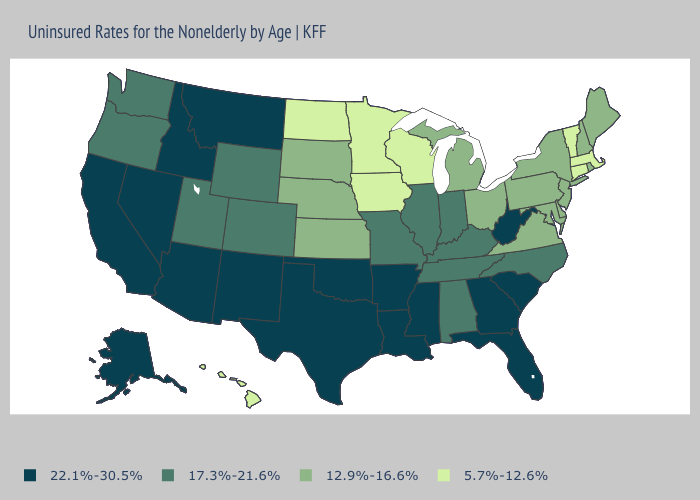Which states have the highest value in the USA?
Give a very brief answer. Alaska, Arizona, Arkansas, California, Florida, Georgia, Idaho, Louisiana, Mississippi, Montana, Nevada, New Mexico, Oklahoma, South Carolina, Texas, West Virginia. Does Hawaii have the lowest value in the USA?
Answer briefly. Yes. Which states hav the highest value in the West?
Give a very brief answer. Alaska, Arizona, California, Idaho, Montana, Nevada, New Mexico. Among the states that border New Hampshire , which have the highest value?
Concise answer only. Maine. Does Vermont have the lowest value in the Northeast?
Answer briefly. Yes. Does Indiana have a higher value than Illinois?
Write a very short answer. No. Name the states that have a value in the range 12.9%-16.6%?
Answer briefly. Delaware, Kansas, Maine, Maryland, Michigan, Nebraska, New Hampshire, New Jersey, New York, Ohio, Pennsylvania, Rhode Island, South Dakota, Virginia. Among the states that border Virginia , does West Virginia have the highest value?
Answer briefly. Yes. Among the states that border Tennessee , does Virginia have the lowest value?
Concise answer only. Yes. Name the states that have a value in the range 22.1%-30.5%?
Quick response, please. Alaska, Arizona, Arkansas, California, Florida, Georgia, Idaho, Louisiana, Mississippi, Montana, Nevada, New Mexico, Oklahoma, South Carolina, Texas, West Virginia. Which states have the lowest value in the USA?
Be succinct. Connecticut, Hawaii, Iowa, Massachusetts, Minnesota, North Dakota, Vermont, Wisconsin. Does the first symbol in the legend represent the smallest category?
Keep it brief. No. Does Ohio have the highest value in the MidWest?
Answer briefly. No. Which states have the highest value in the USA?
Write a very short answer. Alaska, Arizona, Arkansas, California, Florida, Georgia, Idaho, Louisiana, Mississippi, Montana, Nevada, New Mexico, Oklahoma, South Carolina, Texas, West Virginia. Name the states that have a value in the range 22.1%-30.5%?
Give a very brief answer. Alaska, Arizona, Arkansas, California, Florida, Georgia, Idaho, Louisiana, Mississippi, Montana, Nevada, New Mexico, Oklahoma, South Carolina, Texas, West Virginia. 